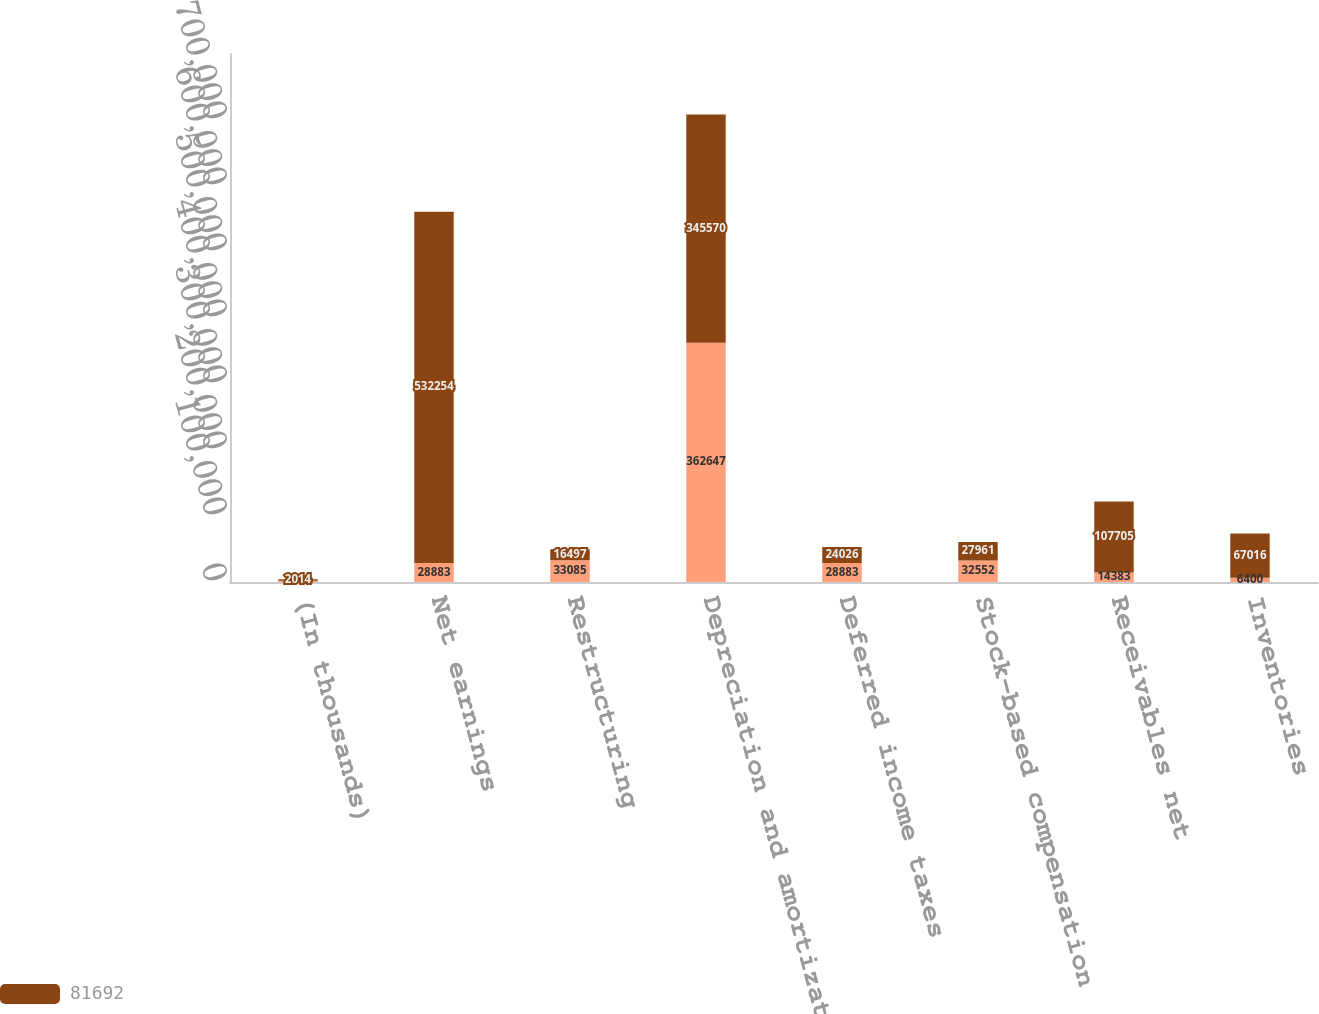Convert chart to OTSL. <chart><loc_0><loc_0><loc_500><loc_500><stacked_bar_chart><ecel><fcel>(In thousands)<fcel>Net earnings<fcel>Restructuring<fcel>Depreciation and amortization<fcel>Deferred income taxes<fcel>Stock-based compensation<fcel>Receivables net<fcel>Inventories<nl><fcel>nan<fcel>2015<fcel>28883<fcel>33085<fcel>362647<fcel>28883<fcel>32552<fcel>14383<fcel>6400<nl><fcel>81692<fcel>2014<fcel>532254<fcel>16497<fcel>345570<fcel>24026<fcel>27961<fcel>107705<fcel>67016<nl></chart> 